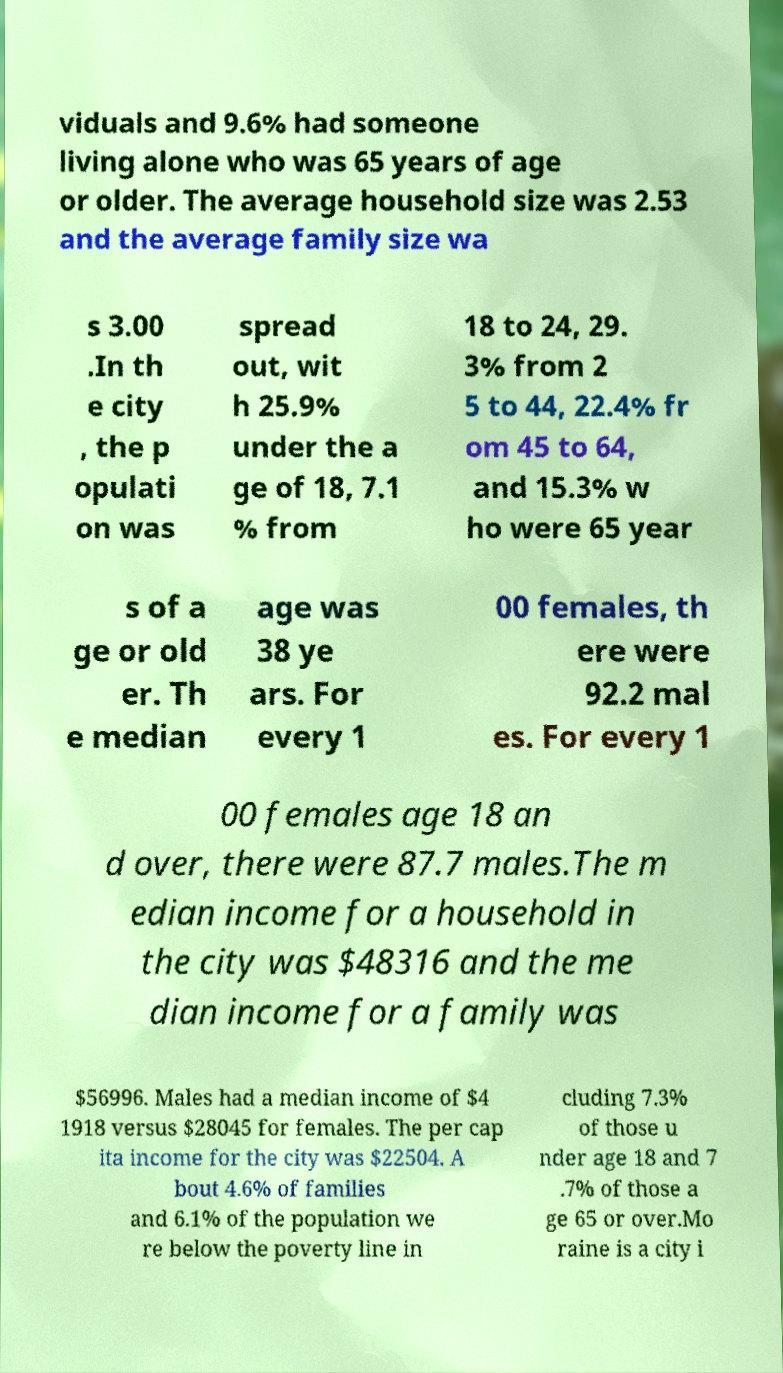Can you read and provide the text displayed in the image?This photo seems to have some interesting text. Can you extract and type it out for me? viduals and 9.6% had someone living alone who was 65 years of age or older. The average household size was 2.53 and the average family size wa s 3.00 .In th e city , the p opulati on was spread out, wit h 25.9% under the a ge of 18, 7.1 % from 18 to 24, 29. 3% from 2 5 to 44, 22.4% fr om 45 to 64, and 15.3% w ho were 65 year s of a ge or old er. Th e median age was 38 ye ars. For every 1 00 females, th ere were 92.2 mal es. For every 1 00 females age 18 an d over, there were 87.7 males.The m edian income for a household in the city was $48316 and the me dian income for a family was $56996. Males had a median income of $4 1918 versus $28045 for females. The per cap ita income for the city was $22504. A bout 4.6% of families and 6.1% of the population we re below the poverty line in cluding 7.3% of those u nder age 18 and 7 .7% of those a ge 65 or over.Mo raine is a city i 